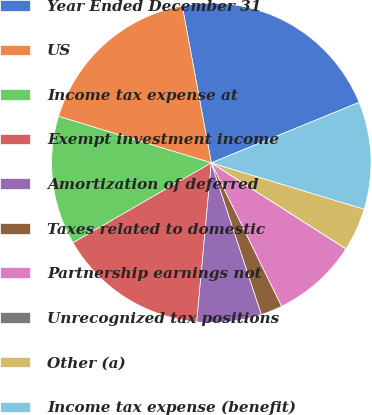Convert chart to OTSL. <chart><loc_0><loc_0><loc_500><loc_500><pie_chart><fcel>Year Ended December 31<fcel>US<fcel>Income tax expense at<fcel>Exempt investment income<fcel>Amortization of deferred<fcel>Taxes related to domestic<fcel>Partnership earnings not<fcel>Unrecognized tax positions<fcel>Other (a)<fcel>Income tax expense (benefit)<nl><fcel>21.73%<fcel>17.38%<fcel>13.04%<fcel>15.21%<fcel>6.53%<fcel>2.18%<fcel>8.7%<fcel>0.01%<fcel>4.35%<fcel>10.87%<nl></chart> 